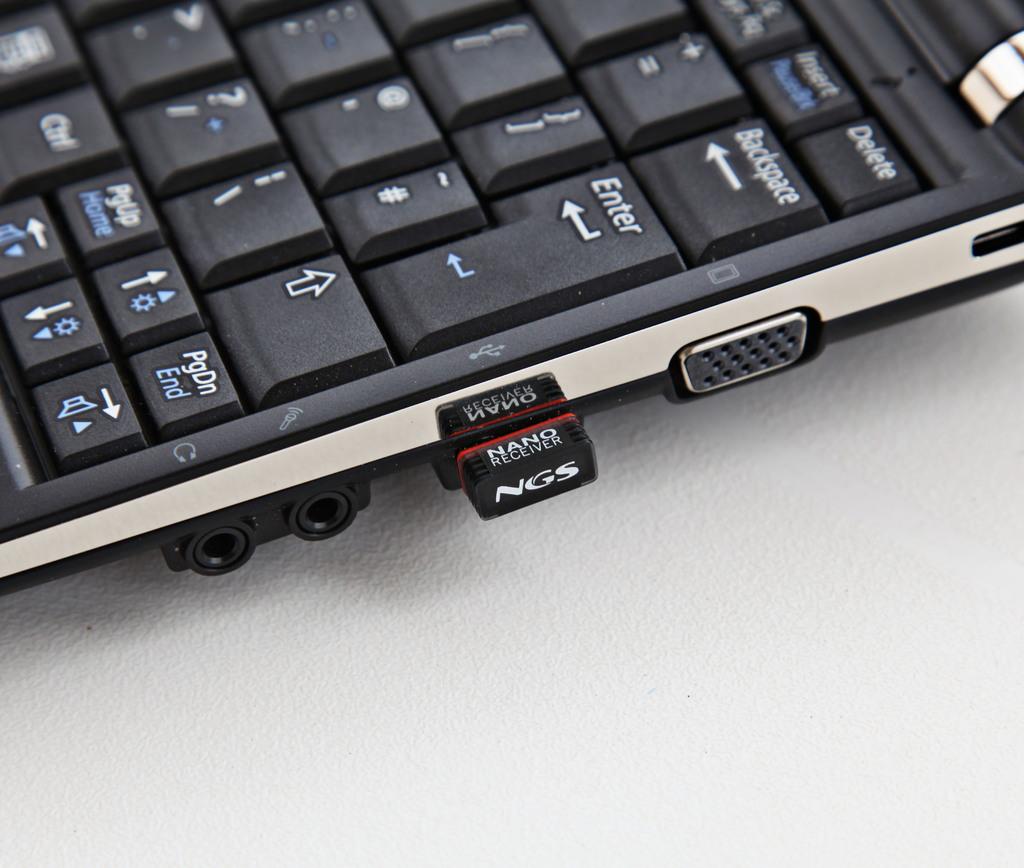Who manufactured this nano receiver?
Your response must be concise. Ngs. Which keyboard key is the nano receiver closest to?
Provide a short and direct response. Enter. 